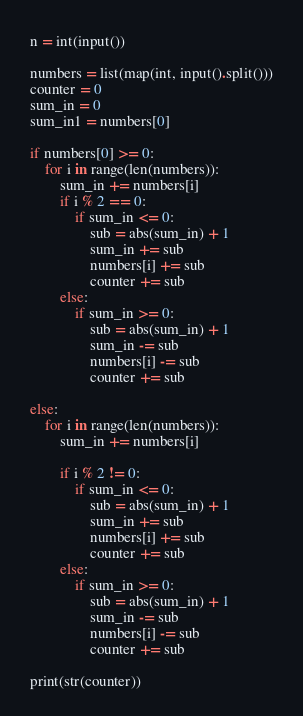Convert code to text. <code><loc_0><loc_0><loc_500><loc_500><_Python_>n = int(input())

numbers = list(map(int, input().split()))
counter = 0
sum_in = 0
sum_in1 = numbers[0]

if numbers[0] >= 0:
    for i in range(len(numbers)):
        sum_in += numbers[i]
        if i % 2 == 0:
            if sum_in <= 0:
                sub = abs(sum_in) + 1
                sum_in += sub
                numbers[i] += sub
                counter += sub
        else:
            if sum_in >= 0:
                sub = abs(sum_in) + 1
                sum_in -= sub
                numbers[i] -= sub
                counter += sub

else:
    for i in range(len(numbers)):
        sum_in += numbers[i]

        if i % 2 != 0:
            if sum_in <= 0:
                sub = abs(sum_in) + 1
                sum_in += sub
                numbers[i] += sub
                counter += sub
        else:
            if sum_in >= 0:
                sub = abs(sum_in) + 1
                sum_in -= sub
                numbers[i] -= sub
                counter += sub

print(str(counter))</code> 